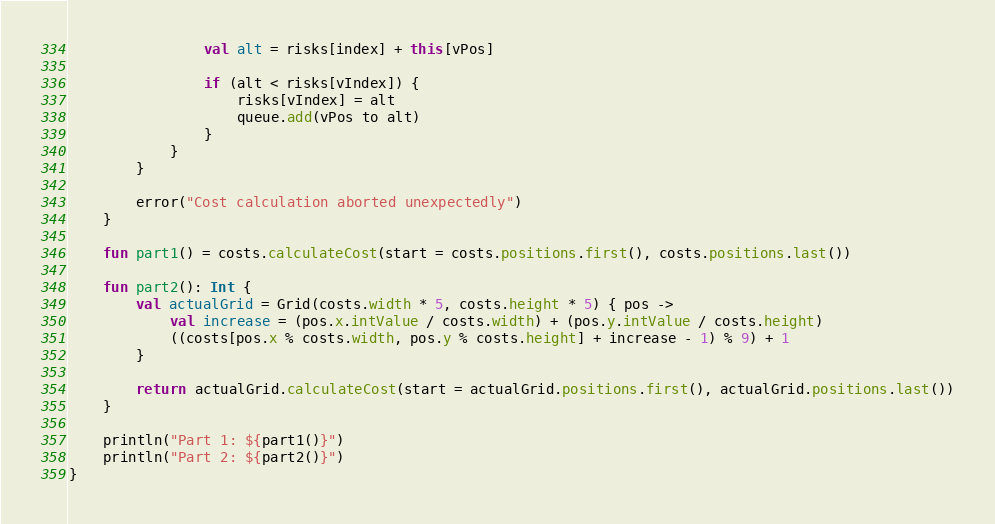Convert code to text. <code><loc_0><loc_0><loc_500><loc_500><_Kotlin_>
                val alt = risks[index] + this[vPos]

                if (alt < risks[vIndex]) {
                    risks[vIndex] = alt
                    queue.add(vPos to alt)
                }
            }
        }

        error("Cost calculation aborted unexpectedly")
    }

    fun part1() = costs.calculateCost(start = costs.positions.first(), costs.positions.last())

    fun part2(): Int {
        val actualGrid = Grid(costs.width * 5, costs.height * 5) { pos ->
            val increase = (pos.x.intValue / costs.width) + (pos.y.intValue / costs.height)
            ((costs[pos.x % costs.width, pos.y % costs.height] + increase - 1) % 9) + 1
        }

        return actualGrid.calculateCost(start = actualGrid.positions.first(), actualGrid.positions.last())
    }

    println("Part 1: ${part1()}")
    println("Part 2: ${part2()}")
}</code> 